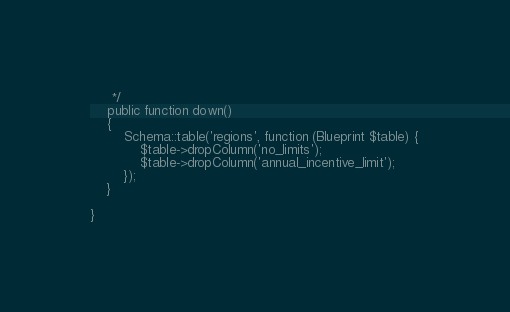<code> <loc_0><loc_0><loc_500><loc_500><_PHP_>     */
    public function down()
    {
        Schema::table('regions', function (Blueprint $table) {
            $table->dropColumn('no_limits');
            $table->dropColumn('annual_incentive_limit');
        });
    }

}
</code> 